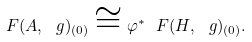<formula> <loc_0><loc_0><loc_500><loc_500>\ F ( A , \ g ) _ { ( 0 ) } \cong \varphi ^ { * } \ F ( H , \ g ) _ { ( 0 ) } .</formula> 